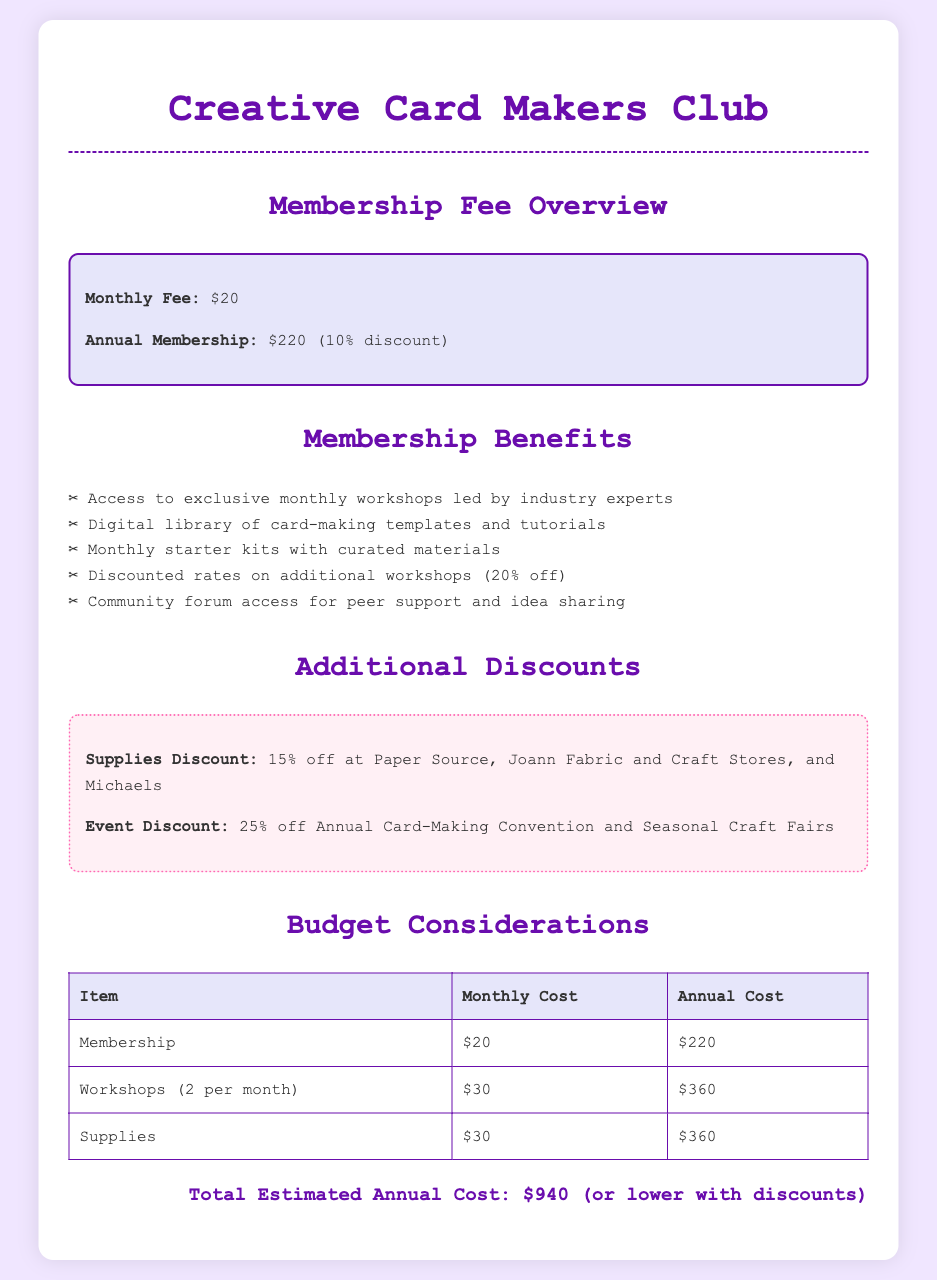What is the monthly membership fee? The document states that the monthly membership fee is $20.
Answer: $20 What is the annual membership fee with the discount applied? The annual membership fee with the 10% discount is stated as $220.
Answer: $220 How much do you save on the annual fee with a monthly membership? Since the monthly fee amounts to $240 annually, and the annual fee is $220, you save $20.
Answer: $20 What is the discount percentage on workshops for members? The document mentions a 20% discount on additional workshops for members.
Answer: 20% How many workshops are included per month? The document states that there are 2 workshops provided each month.
Answer: 2 What is the monthly cost for supplies? According to the budget table, the cost for supplies is noted as $30 per month.
Answer: $30 What is the total estimated annual cost? The total estimated annual cost given in the document is $940.
Answer: $940 What discount do members receive on supplies at major craft stores? Members receive a 15% discount on supplies at selected stores like Paper Source and Michaels.
Answer: 15% How many benefits are listed for membership? The section detailing membership benefits lists a total of 5 distinct benefits.
Answer: 5 